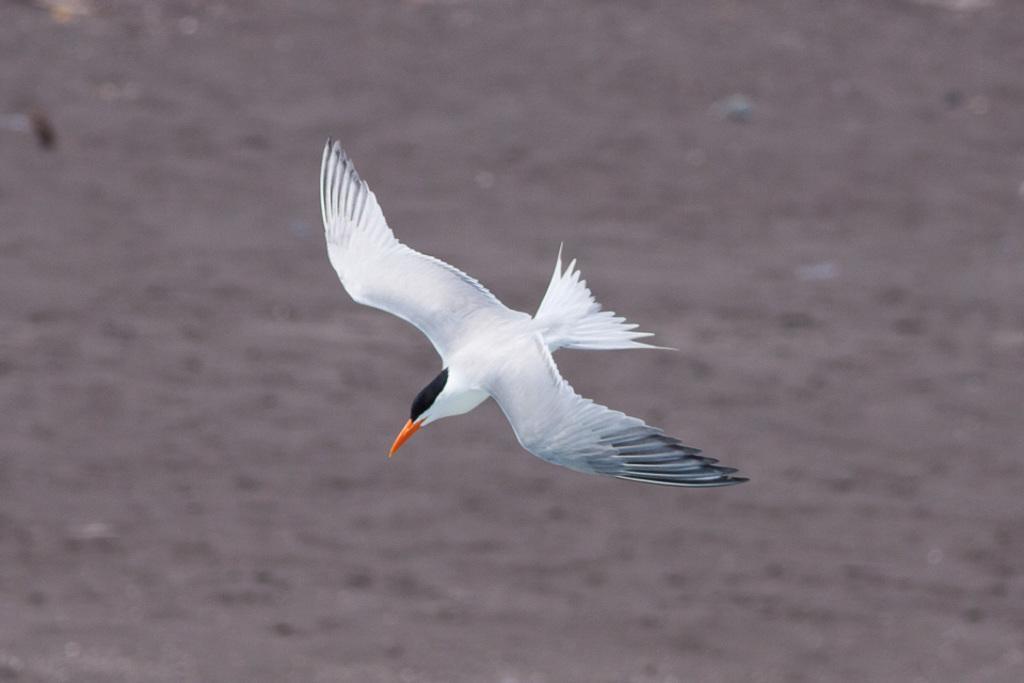In one or two sentences, can you explain what this image depicts? In this picture there is a white color bird with orange beak is flying. At the bottom there is water. 